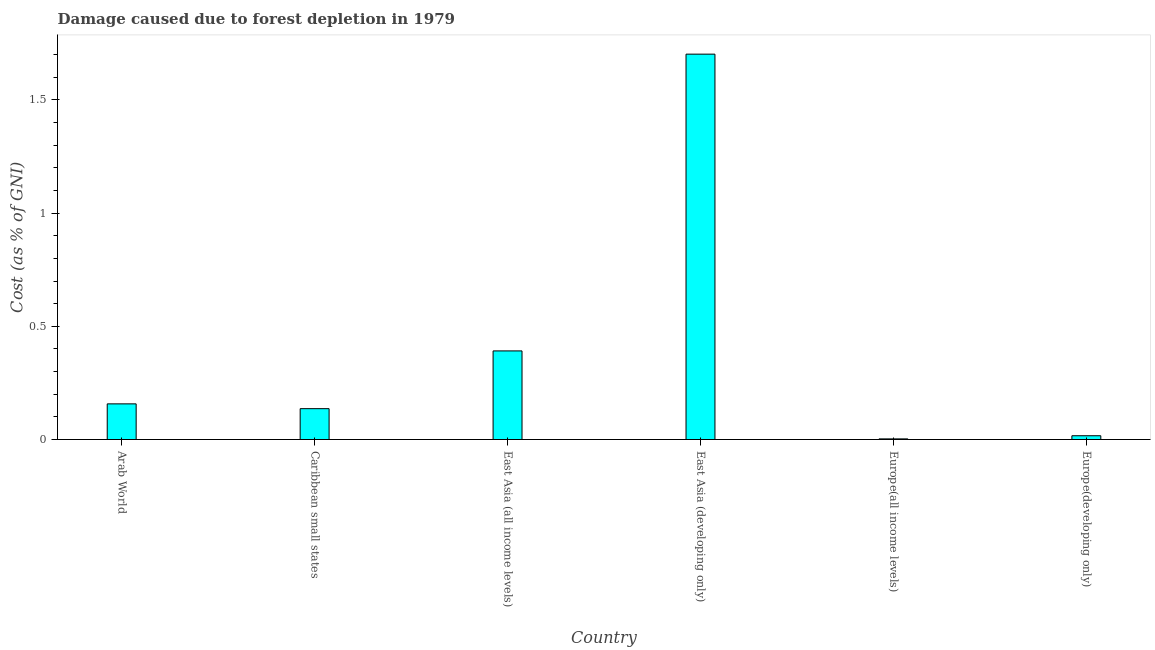Does the graph contain any zero values?
Give a very brief answer. No. Does the graph contain grids?
Ensure brevity in your answer.  No. What is the title of the graph?
Your answer should be very brief. Damage caused due to forest depletion in 1979. What is the label or title of the Y-axis?
Make the answer very short. Cost (as % of GNI). What is the damage caused due to forest depletion in East Asia (all income levels)?
Provide a short and direct response. 0.39. Across all countries, what is the maximum damage caused due to forest depletion?
Your answer should be compact. 1.7. Across all countries, what is the minimum damage caused due to forest depletion?
Offer a terse response. 0. In which country was the damage caused due to forest depletion maximum?
Offer a very short reply. East Asia (developing only). In which country was the damage caused due to forest depletion minimum?
Your answer should be very brief. Europe(all income levels). What is the sum of the damage caused due to forest depletion?
Your response must be concise. 2.41. What is the difference between the damage caused due to forest depletion in Europe(all income levels) and Europe(developing only)?
Provide a short and direct response. -0.01. What is the average damage caused due to forest depletion per country?
Your response must be concise. 0.4. What is the median damage caused due to forest depletion?
Ensure brevity in your answer.  0.15. In how many countries, is the damage caused due to forest depletion greater than 0.8 %?
Keep it short and to the point. 1. What is the ratio of the damage caused due to forest depletion in Europe(all income levels) to that in Europe(developing only)?
Ensure brevity in your answer.  0.17. Is the difference between the damage caused due to forest depletion in East Asia (all income levels) and Europe(all income levels) greater than the difference between any two countries?
Provide a short and direct response. No. What is the difference between the highest and the second highest damage caused due to forest depletion?
Provide a succinct answer. 1.31. What is the difference between the highest and the lowest damage caused due to forest depletion?
Keep it short and to the point. 1.7. In how many countries, is the damage caused due to forest depletion greater than the average damage caused due to forest depletion taken over all countries?
Keep it short and to the point. 1. Are the values on the major ticks of Y-axis written in scientific E-notation?
Ensure brevity in your answer.  No. What is the Cost (as % of GNI) of Arab World?
Offer a terse response. 0.16. What is the Cost (as % of GNI) of Caribbean small states?
Provide a short and direct response. 0.14. What is the Cost (as % of GNI) of East Asia (all income levels)?
Provide a short and direct response. 0.39. What is the Cost (as % of GNI) of East Asia (developing only)?
Keep it short and to the point. 1.7. What is the Cost (as % of GNI) of Europe(all income levels)?
Your response must be concise. 0. What is the Cost (as % of GNI) of Europe(developing only)?
Ensure brevity in your answer.  0.02. What is the difference between the Cost (as % of GNI) in Arab World and Caribbean small states?
Your response must be concise. 0.02. What is the difference between the Cost (as % of GNI) in Arab World and East Asia (all income levels)?
Keep it short and to the point. -0.23. What is the difference between the Cost (as % of GNI) in Arab World and East Asia (developing only)?
Your response must be concise. -1.54. What is the difference between the Cost (as % of GNI) in Arab World and Europe(all income levels)?
Offer a terse response. 0.15. What is the difference between the Cost (as % of GNI) in Arab World and Europe(developing only)?
Offer a very short reply. 0.14. What is the difference between the Cost (as % of GNI) in Caribbean small states and East Asia (all income levels)?
Ensure brevity in your answer.  -0.26. What is the difference between the Cost (as % of GNI) in Caribbean small states and East Asia (developing only)?
Ensure brevity in your answer.  -1.57. What is the difference between the Cost (as % of GNI) in Caribbean small states and Europe(all income levels)?
Make the answer very short. 0.13. What is the difference between the Cost (as % of GNI) in Caribbean small states and Europe(developing only)?
Your response must be concise. 0.12. What is the difference between the Cost (as % of GNI) in East Asia (all income levels) and East Asia (developing only)?
Keep it short and to the point. -1.31. What is the difference between the Cost (as % of GNI) in East Asia (all income levels) and Europe(all income levels)?
Your answer should be very brief. 0.39. What is the difference between the Cost (as % of GNI) in East Asia (all income levels) and Europe(developing only)?
Offer a very short reply. 0.37. What is the difference between the Cost (as % of GNI) in East Asia (developing only) and Europe(all income levels)?
Your answer should be very brief. 1.7. What is the difference between the Cost (as % of GNI) in East Asia (developing only) and Europe(developing only)?
Give a very brief answer. 1.69. What is the difference between the Cost (as % of GNI) in Europe(all income levels) and Europe(developing only)?
Your response must be concise. -0.01. What is the ratio of the Cost (as % of GNI) in Arab World to that in Caribbean small states?
Your answer should be very brief. 1.16. What is the ratio of the Cost (as % of GNI) in Arab World to that in East Asia (all income levels)?
Your answer should be compact. 0.4. What is the ratio of the Cost (as % of GNI) in Arab World to that in East Asia (developing only)?
Your answer should be very brief. 0.09. What is the ratio of the Cost (as % of GNI) in Arab World to that in Europe(all income levels)?
Keep it short and to the point. 55.6. What is the ratio of the Cost (as % of GNI) in Arab World to that in Europe(developing only)?
Ensure brevity in your answer.  9.42. What is the ratio of the Cost (as % of GNI) in Caribbean small states to that in East Asia (all income levels)?
Ensure brevity in your answer.  0.35. What is the ratio of the Cost (as % of GNI) in Caribbean small states to that in Europe(all income levels)?
Your answer should be compact. 48.11. What is the ratio of the Cost (as % of GNI) in Caribbean small states to that in Europe(developing only)?
Offer a very short reply. 8.15. What is the ratio of the Cost (as % of GNI) in East Asia (all income levels) to that in East Asia (developing only)?
Give a very brief answer. 0.23. What is the ratio of the Cost (as % of GNI) in East Asia (all income levels) to that in Europe(all income levels)?
Offer a terse response. 138.18. What is the ratio of the Cost (as % of GNI) in East Asia (all income levels) to that in Europe(developing only)?
Ensure brevity in your answer.  23.42. What is the ratio of the Cost (as % of GNI) in East Asia (developing only) to that in Europe(all income levels)?
Give a very brief answer. 600.98. What is the ratio of the Cost (as % of GNI) in East Asia (developing only) to that in Europe(developing only)?
Keep it short and to the point. 101.84. What is the ratio of the Cost (as % of GNI) in Europe(all income levels) to that in Europe(developing only)?
Make the answer very short. 0.17. 